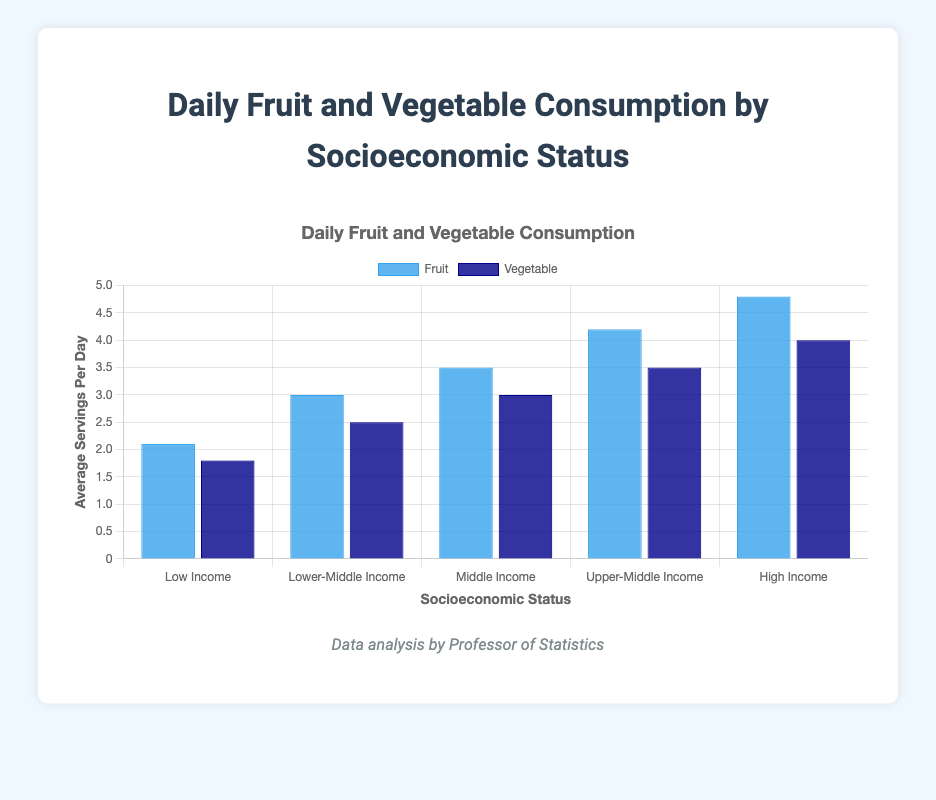Which socioeconomic status category has the highest average daily fruit consumption? The "High Income" category has the highest fruit consumption at 4.8 servings per day, as indicated by the tallest blue bar.
Answer: High Income By how much does the average daily vegetable consumption of "High Income" differ from that of "Low Income"? "High Income" has an average vegetable consumption of 4.0 servings per day, while "Low Income" has 1.8 servings per day. The difference is 4.0 - 1.8 = 2.2 servings.
Answer: 2.2 servings What is the total average daily consumption (fruit + vegetable) for the "Upper-Middle Income" group? The "Upper-Middle Income" group consumes 4.2 servings of fruit and 3.5 servings of vegetables daily. Sum these values to find the total: 4.2 + 3.5 = 7.7 servings.
Answer: 7.7 servings Which income group has the lowest average daily vegetable consumption, and by how much is it lower than the "Middle Income" group's consumption? The "Low Income" group has the lowest vegetable consumption at 1.8 servings per day. The "Middle Income" group consumes 3.0 servings per day. The difference is 3.0 - 1.8 = 1.2 servings.
Answer: Low Income, 1.2 servings Compare the average daily fruit consumption between "Low Income" and "Upper-Middle Income". Which group consumes more and by how much? "Low Income" consumes 2.1 servings of fruit daily, while "Upper-Middle Income" consumes 4.2 servings daily. The difference is 4.2 - 2.1 = 2.1 servings. Upper-Middle Income consumes more.
Answer: Upper-Middle Income, 2.1 servings What is the combined average daily vegetable consumption for "Lower-Middle Income" and "Middle Income"? "Lower-Middle Income" has a vegetable consumption of 2.5 servings per day, and "Middle Income" has 3.0 servings per day. The combined consumption is 2.5 + 3.0 = 5.5 servings.
Answer: 5.5 servings Which category has the smallest difference between fruit and vegetable consumption, and what is the value of this difference? For "Middle Income", fruit consumption is 3.5 servings and vegetable consumption is 3.0 servings. The difference is 3.5 - 3.0 = 0.5 servings. This is the smallest difference among all categories.
Answer: Middle Income, 0.5 servings How many categories consume more than 3.0 servings daily of both fruits and vegetables? "Middle Income", "Upper-Middle Income", and "High Income" categories each consume more than 3.0 servings daily of both fruits (3.5, 4.2, 4.8) and vegetables (3.0, 3.5, 4.0). There are three such categories.
Answer: 3 categories What is the average (mean) fruit consumption across all socioeconomic statuses? Add the fruit consumption values for all categories (2.1, 3.0, 3.5, 4.2, 4.8), then divide by the number of categories (5): (2.1 + 3.0 + 3.5 + 4.2 + 4.8)/5 = 17.6/5 = 3.52 servings.
Answer: 3.52 servings 